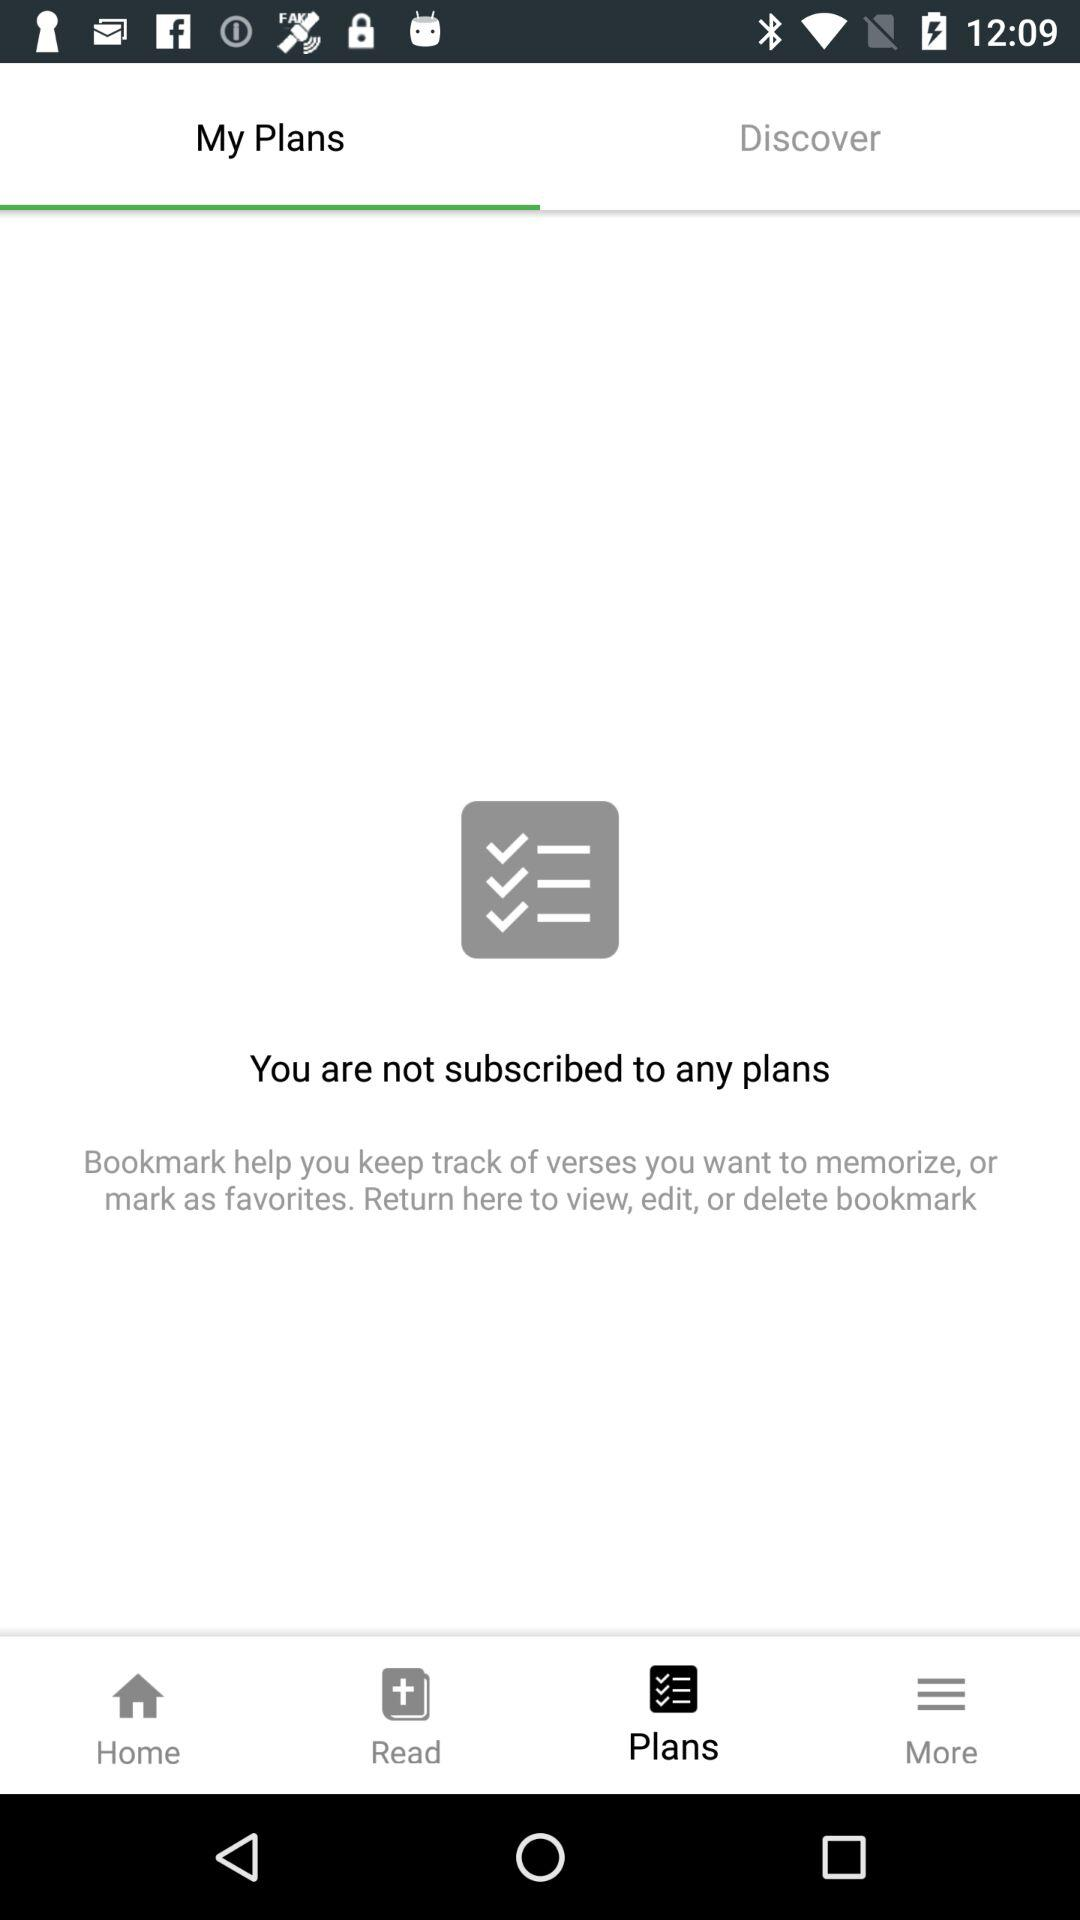Are there any recommendations on how to start using plans with this app? I'd recommend exploring the 'Discover' section suggested in the top-right of the image. It's designed to help users find and subscribe to plans that fit their needs or interests. Is there a way to track my progress with the plans? Typically, apps with planning features include progress tracking. It's likely that once you have plans in place, the app will offer options to track your progression through various statuses or completion percentages. 